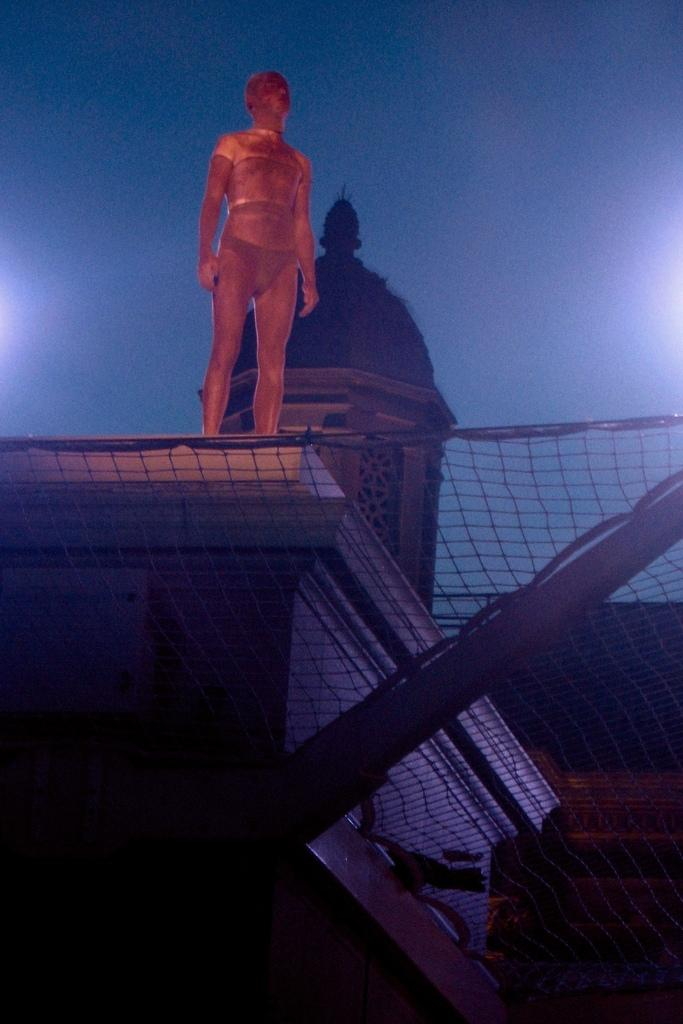What is located at the bottom of the image? There is a net at the bottom of the image. What can be seen in the middle of the image? There is a statue on a building in the middle of the image. What is visible in the background of the image? The background of the image appears to be the sky. Can you tell me how many people are talking in the basket in the image? There is no basket or people talking present in the image. 